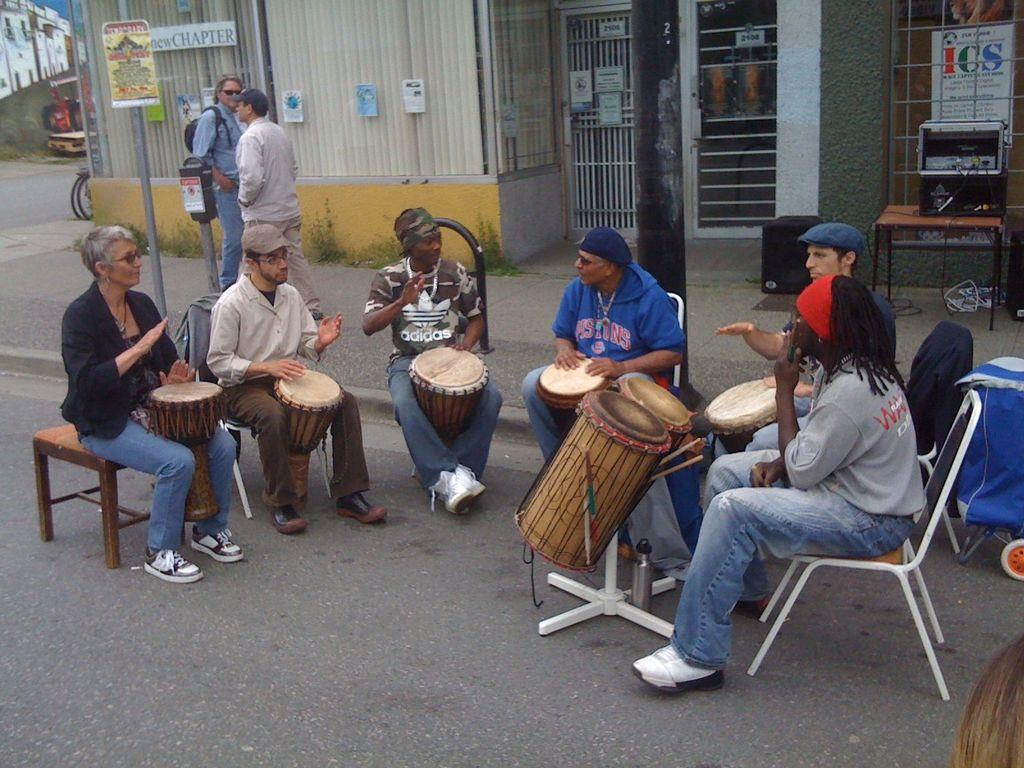What are the two persons in the image doing? The two persons are walking on the road. What is the group of people doing in the image? The group of people is playing drums. Can you describe the setting where the group of people is playing drums? The group of people is sitting on chairs in the image. What is visible in the background of the image? There is a building in the image. Can you see any hens or worms in the image? No, there are no hens or worms present in the image. How many dogs are visible in the image? There are no dogs visible in the image. 